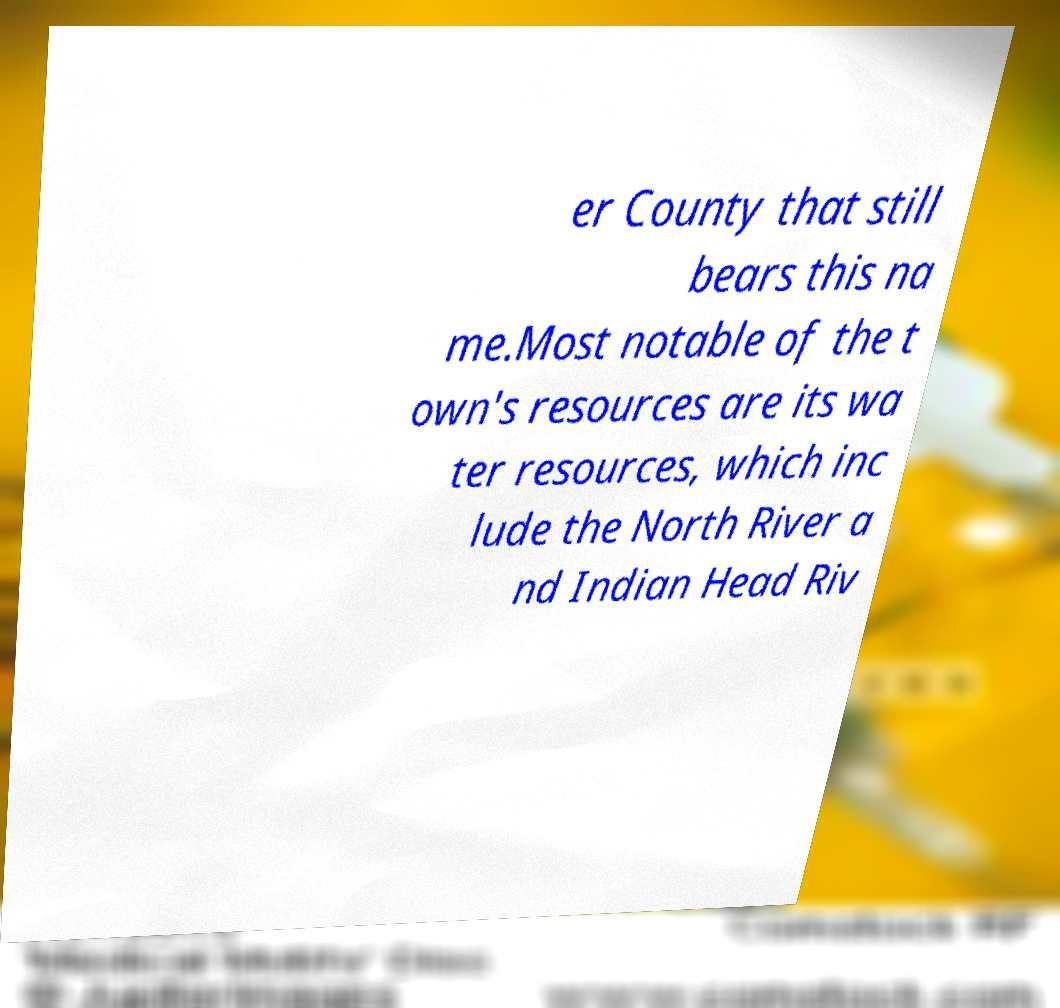Can you read and provide the text displayed in the image?This photo seems to have some interesting text. Can you extract and type it out for me? er County that still bears this na me.Most notable of the t own's resources are its wa ter resources, which inc lude the North River a nd Indian Head Riv 